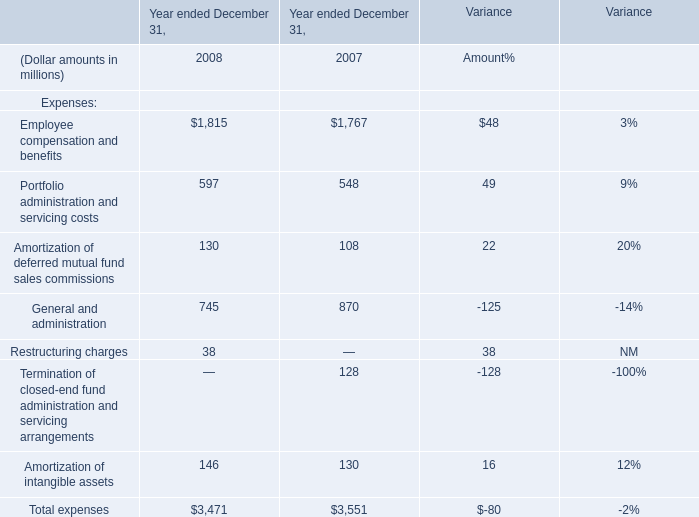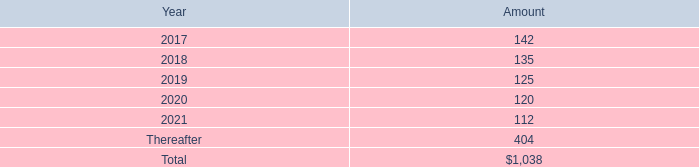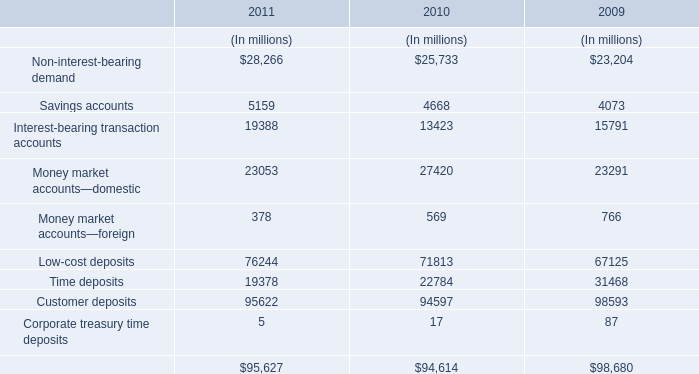What will Employee compensation and benefits be like in 2009 if it develops with the same increasing rate as current? (in million) 
Computations: (1815 + ((1815 * (1815 - 1767)) / 1767))
Answer: 1864.3039. 